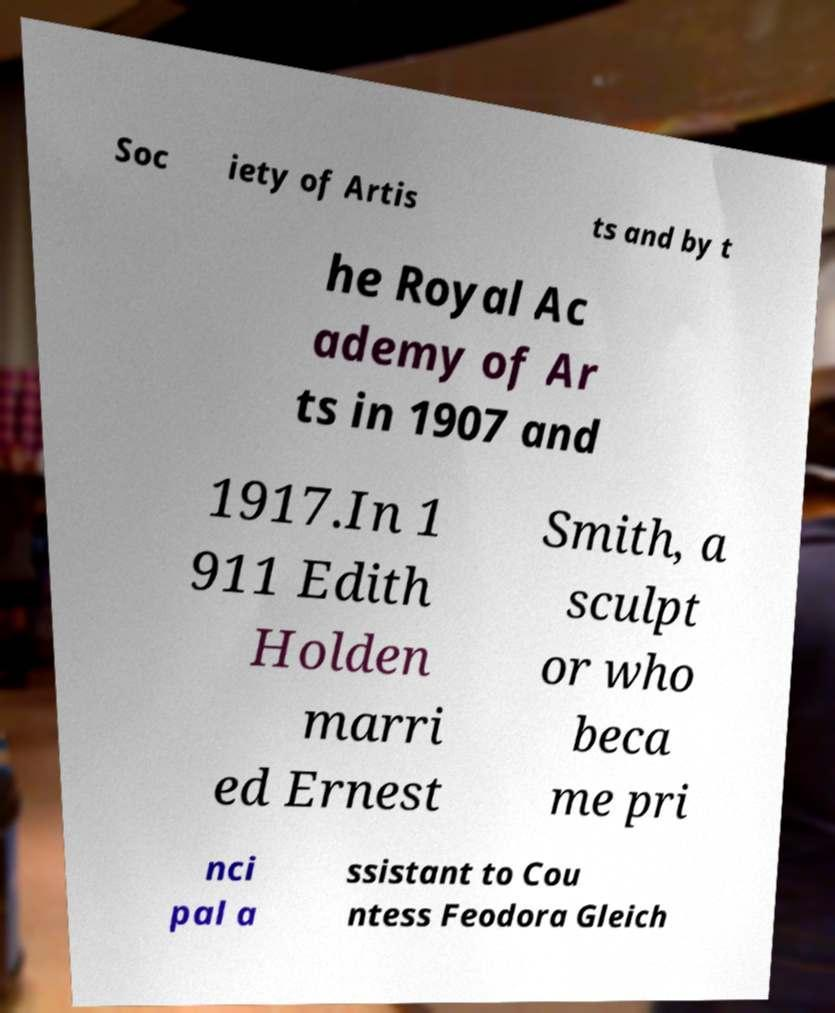Please identify and transcribe the text found in this image. Soc iety of Artis ts and by t he Royal Ac ademy of Ar ts in 1907 and 1917.In 1 911 Edith Holden marri ed Ernest Smith, a sculpt or who beca me pri nci pal a ssistant to Cou ntess Feodora Gleich 